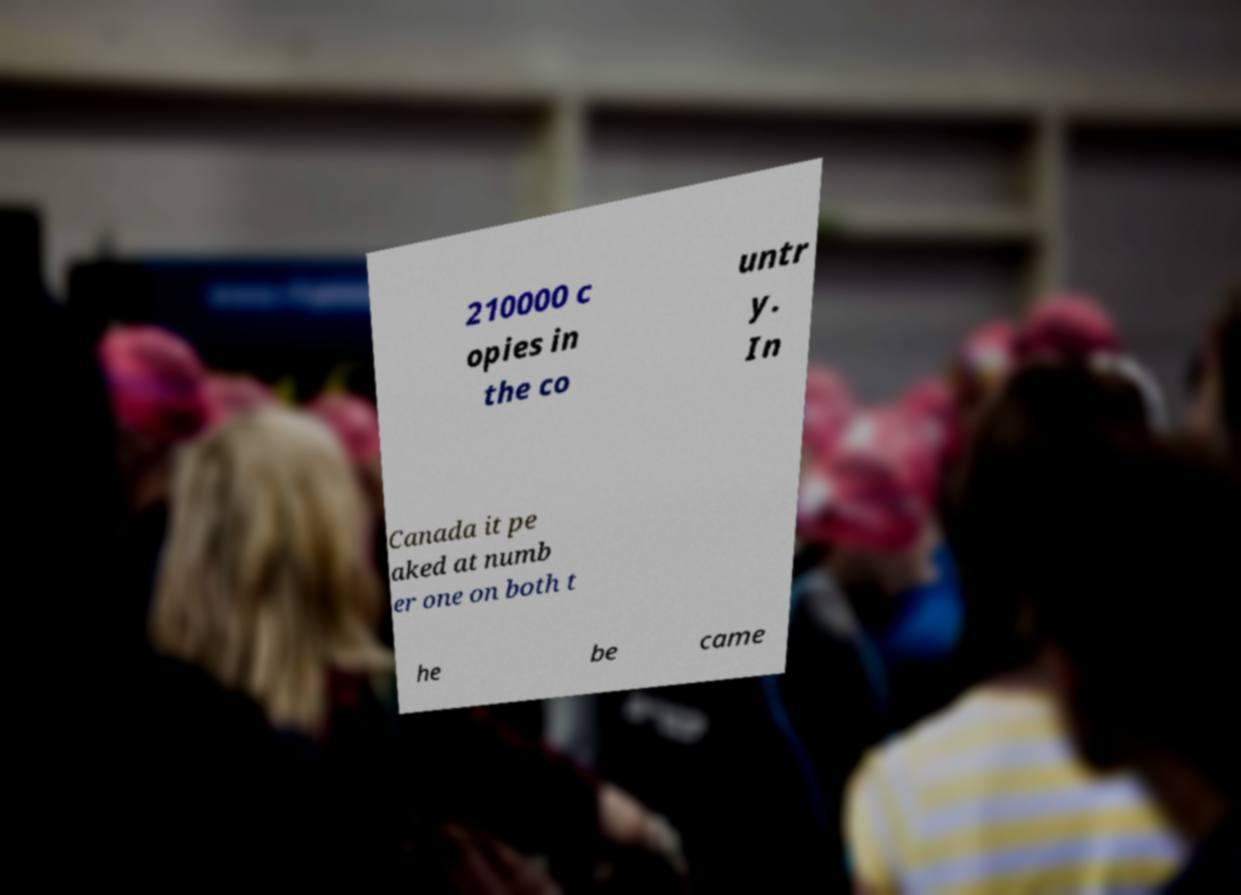What messages or text are displayed in this image? I need them in a readable, typed format. 210000 c opies in the co untr y. In Canada it pe aked at numb er one on both t he be came 